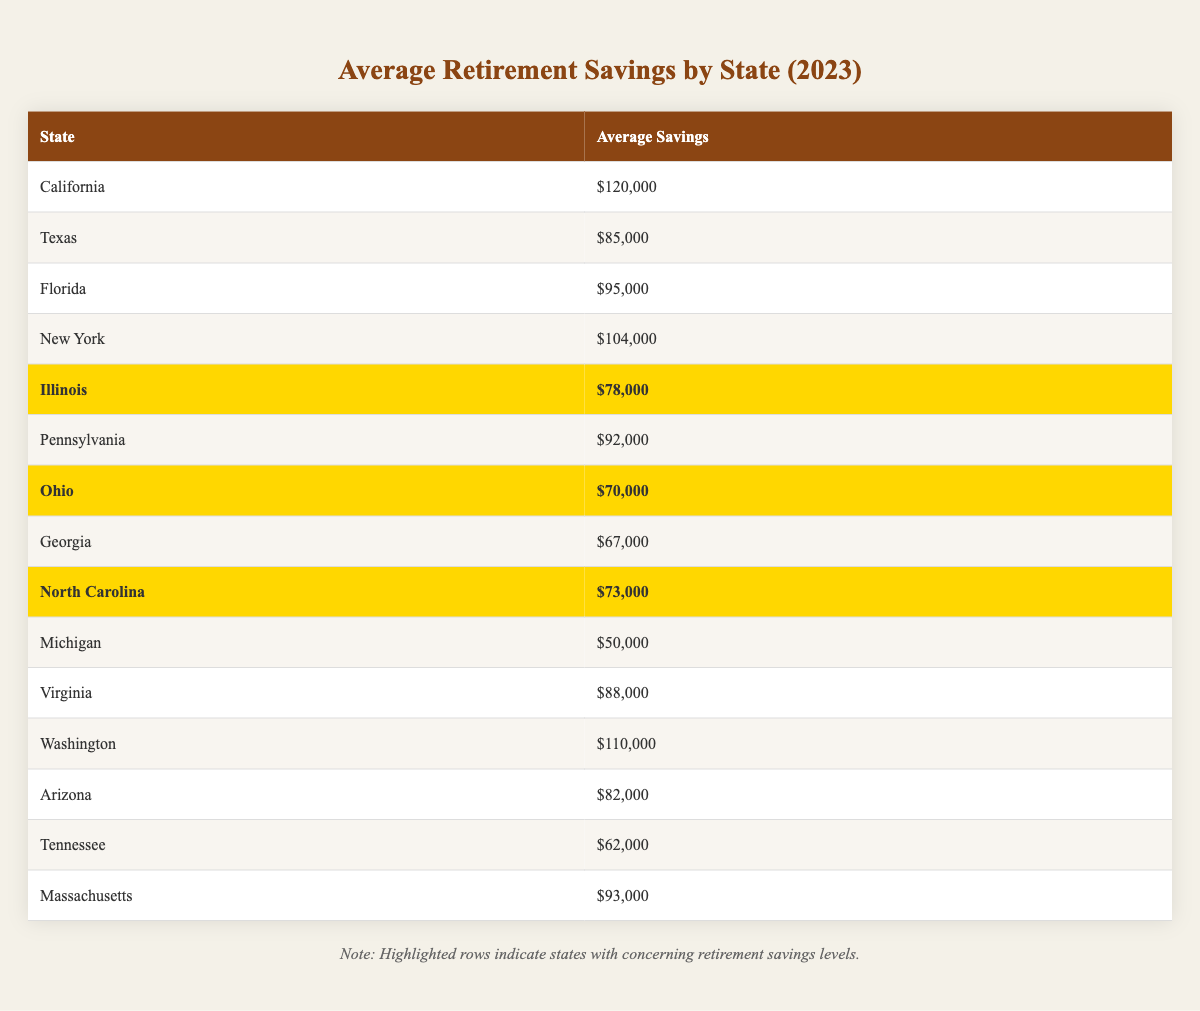What is the average retirement savings amount in California? According to the table, California's average retirement savings amount is provided directly, which is $120,000.
Answer: $120,000 Which state has the lowest average retirement savings? By looking at the table, Michigan has the lowest average retirement savings, listed as $50,000.
Answer: Michigan How much more does California save on average compared to Illinois? California's average savings are $120,000 and Illinois' are $78,000. The difference is calculated as $120,000 - $78,000 = $42,000.
Answer: $42,000 Is the average retirement savings in Ohio considered concerning? Ohio’s average retirement savings are $70,000, which is highlighted in the table as concerning; thus, the answer is yes.
Answer: Yes What is the average savings for the five states with the highest retirement savings? The states with the highest average savings are California ($120,000), Washington ($110,000), New York ($104,000), Florida ($95,000), and Massachusetts ($93,000). The sum is $120,000 + $110,000 + $104,000 + $95,000 + $93,000 = $522,000. To find the average, divide by 5: $522,000 / 5 = $104,400.
Answer: $104,400 Which state has average retirement savings greater than $90,000 but less than $100,000? Scanning the table, Florida has average savings of $95,000, which meets this criterion, while others like New York and Massachusetts are either higher or lower.
Answer: Florida How many states have an average retirement savings under $80,000? The states with averages under $80,000 are Illinois ($78,000), Ohio ($70,000), and Georgia ($67,000), making a total of 3 states.
Answer: 3 What is the total retirement savings for the states that are highlighted as concerning? The highlighted states are Illinois ($78,000), Ohio ($70,000), and North Carolina ($73,000). Adding these together gives $78,000 + $70,000 + $73,000 = $221,000.
Answer: $221,000 Are retirement savings in Virginia considered concerning? Virginia has an average savings amount of $88,000, which is not highlighted in the table; therefore, it is not concerning.
Answer: No What is the difference in average savings between the highest and the lowest state? California has the highest average savings ($120,000) and Michigan has the lowest ($50,000). The difference is $120,000 - $50,000 = $70,000.
Answer: $70,000 